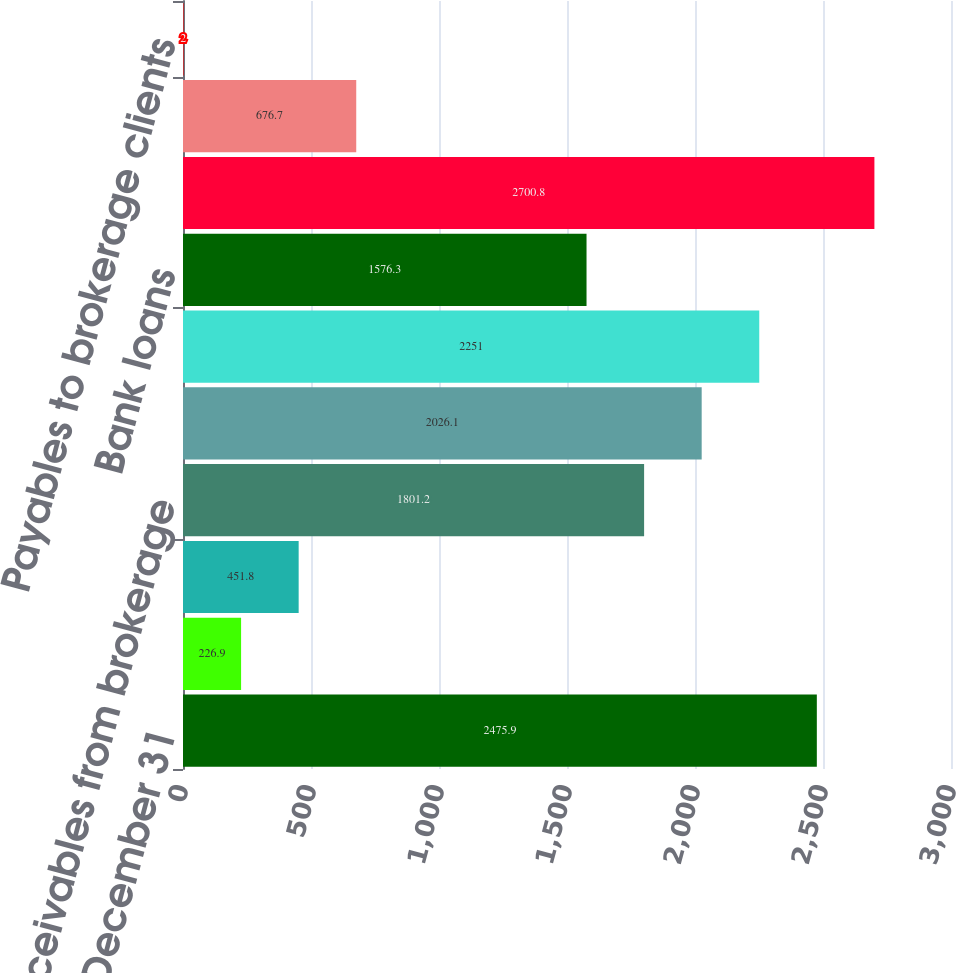<chart> <loc_0><loc_0><loc_500><loc_500><bar_chart><fcel>Year Ended December 31<fcel>Cash and cash equivalents<fcel>Cash and investments<fcel>Receivables from brokerage<fcel>Securities available for sale<fcel>Securities held to maturity<fcel>Bank loans<fcel>Total interest-earning assets<fcel>Bank deposits<fcel>Payables to brokerage clients<nl><fcel>2475.9<fcel>226.9<fcel>451.8<fcel>1801.2<fcel>2026.1<fcel>2251<fcel>1576.3<fcel>2700.8<fcel>676.7<fcel>2<nl></chart> 